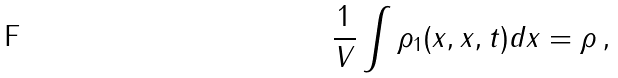<formula> <loc_0><loc_0><loc_500><loc_500>\frac { 1 } { V } \int \rho _ { 1 } ( x , x , t ) d x = \rho \, ,</formula> 